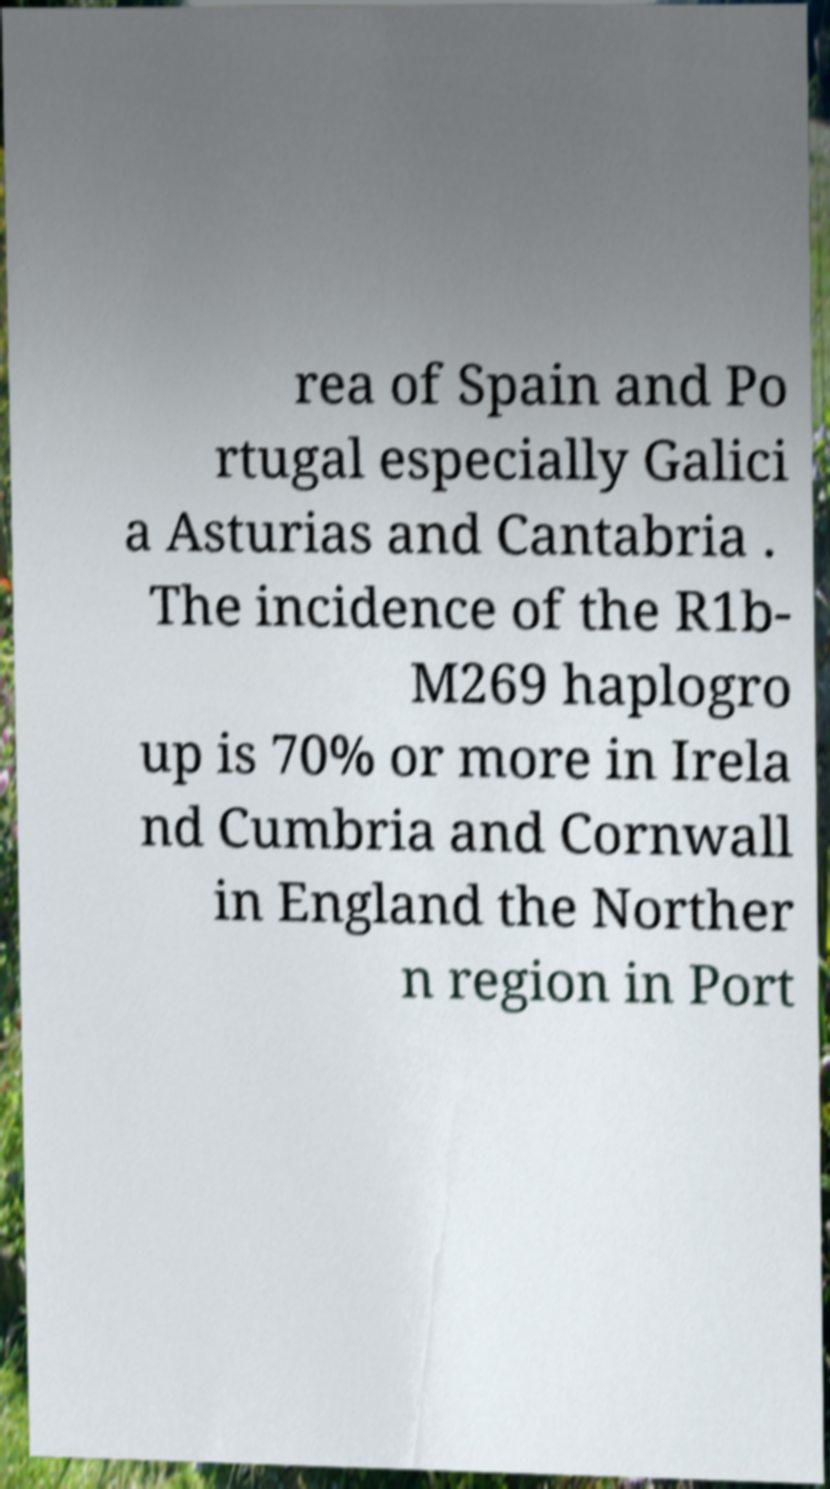Can you accurately transcribe the text from the provided image for me? rea of Spain and Po rtugal especially Galici a Asturias and Cantabria . The incidence of the R1b- M269 haplogro up is 70% or more in Irela nd Cumbria and Cornwall in England the Norther n region in Port 